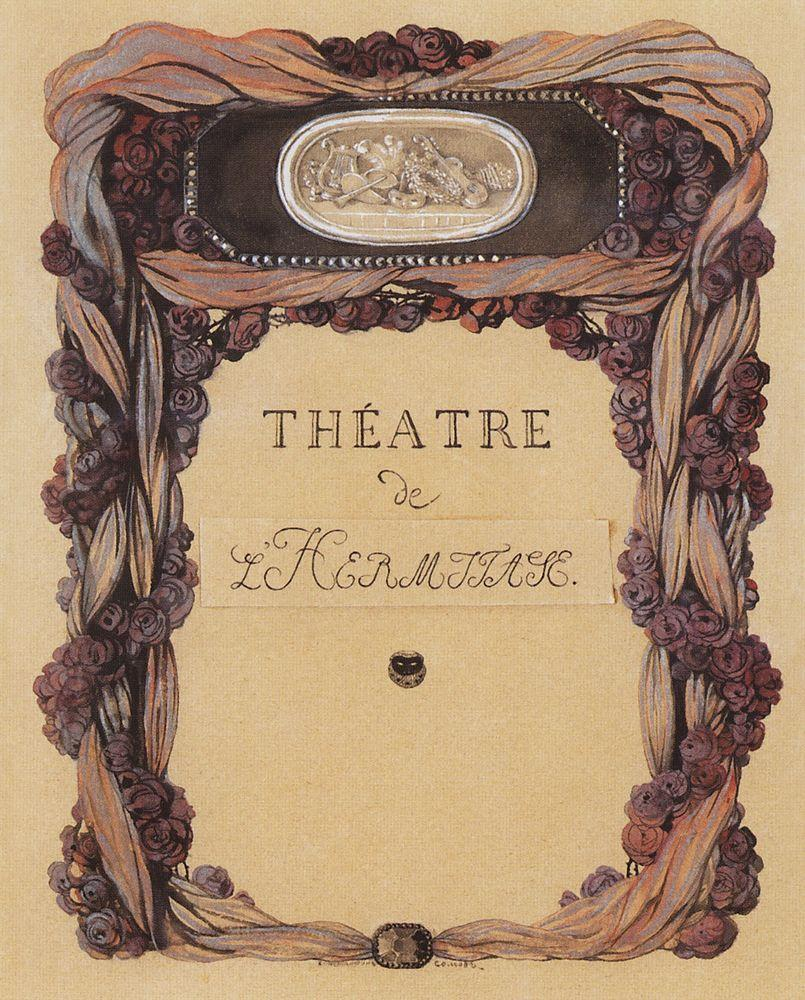Can you describe the main features of this image for me?
 The image is a captivating representation of Art Nouveau poster art. The central focus is an oval mirror, which reflects a serene garden scene featuring a man and a woman. The mirror is framed by a decorative border adorned with purple and red roses, adding a touch of nature to the composition. The background is predominantly beige, providing a neutral canvas that allows the vibrant colors of the roses and the mirror scene to stand out. At the bottom of the poster, the text "Théâtre de L'Horloge" is inscribed in black, indicating that this artwork might be associated with a theater of the same name. The overall composition and style are characteristic of the Art Nouveau genre, known for its intricate designs and emphasis on natural forms. 